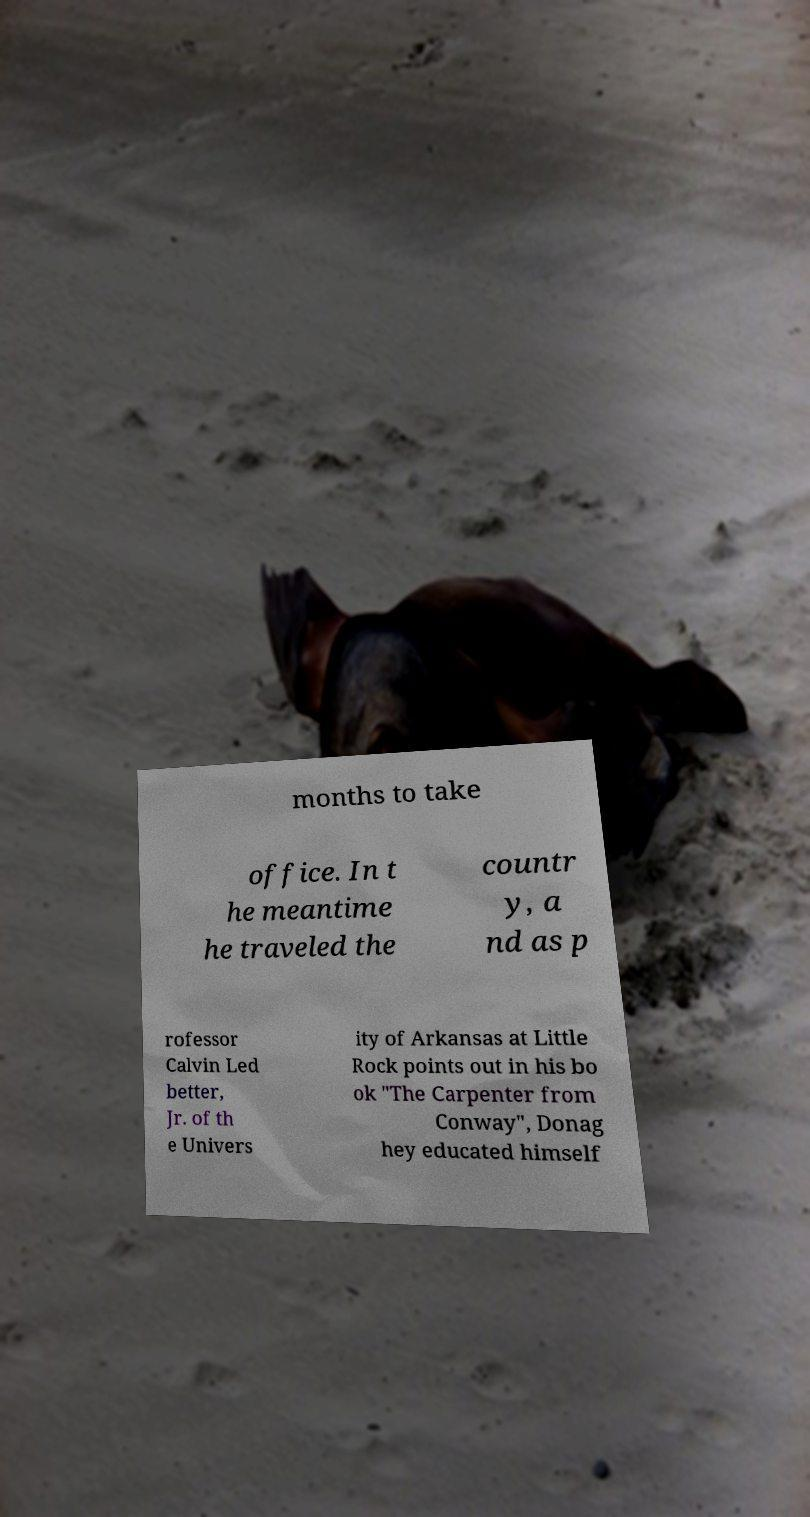Can you read and provide the text displayed in the image?This photo seems to have some interesting text. Can you extract and type it out for me? months to take office. In t he meantime he traveled the countr y, a nd as p rofessor Calvin Led better, Jr. of th e Univers ity of Arkansas at Little Rock points out in his bo ok "The Carpenter from Conway", Donag hey educated himself 